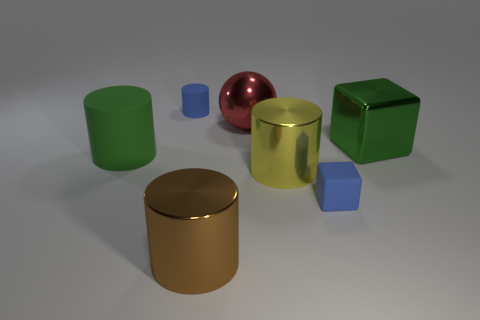How does the lighting in the scene affect the appearance of the objects? The lighting in the scene casts soft shadows and highlights that enhance the three-dimensionality of the objects. The reflective properties of the metallic sphere are particularly accentuated, creating a bright spot and reflections that provide a sense of its smooth texture. The light also affects how we perceive the colors of the objects, giving them depth and bringing out the different shades on their surfaces. 